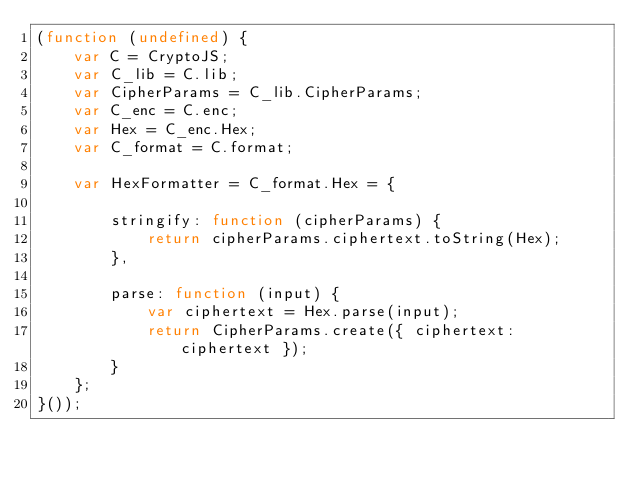<code> <loc_0><loc_0><loc_500><loc_500><_JavaScript_>(function (undefined) {
    var C = CryptoJS;
    var C_lib = C.lib;
    var CipherParams = C_lib.CipherParams;
    var C_enc = C.enc;
    var Hex = C_enc.Hex;
    var C_format = C.format;

    var HexFormatter = C_format.Hex = {

        stringify: function (cipherParams) {
            return cipherParams.ciphertext.toString(Hex);
        },

        parse: function (input) {
            var ciphertext = Hex.parse(input);
            return CipherParams.create({ ciphertext: ciphertext });
        }
    };
}());
</code> 